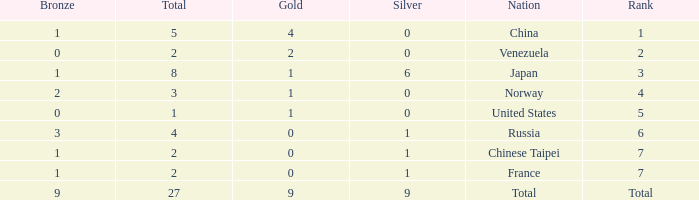What is the sum of Total when rank is 2? 2.0. 